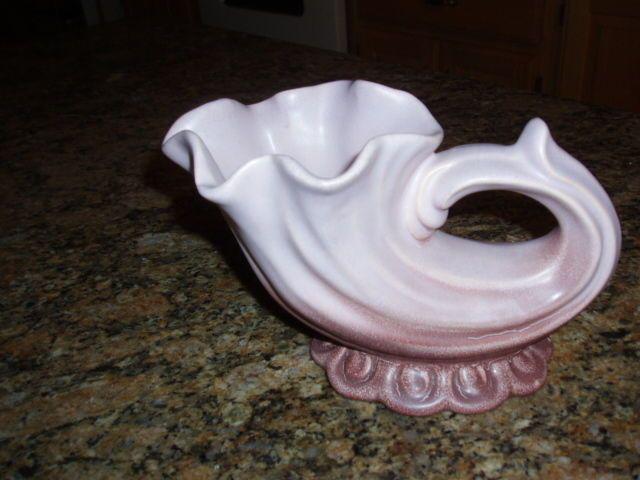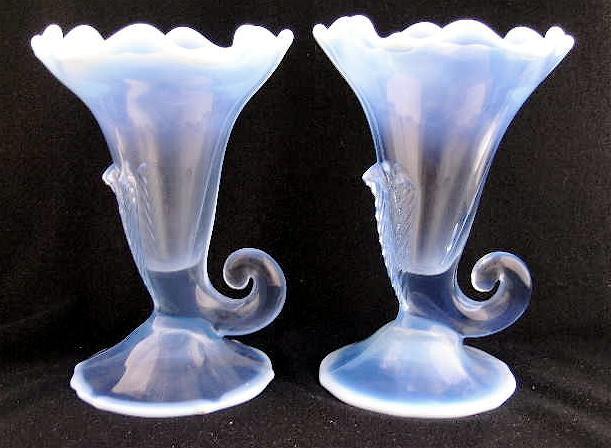The first image is the image on the left, the second image is the image on the right. For the images shown, is this caption "The vases have a floral theme on the front" true? Answer yes or no. No. The first image is the image on the left, the second image is the image on the right. Assess this claim about the two images: "One of the images shows two identical vases next to each other.". Correct or not? Answer yes or no. Yes. 